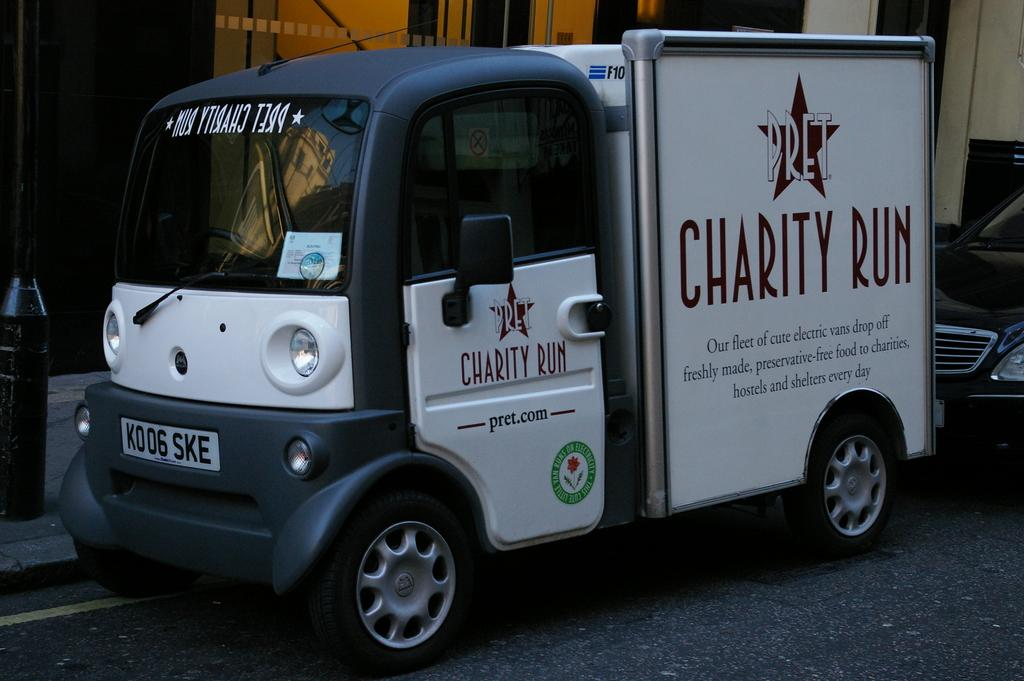What type of objects are present in the image? There are vehicles in the image. What can be found on the vehicles? There is text and logos on the vehicles. What is visible in the background of the image? There is a building in the background of the image. Can you describe another object in the image? There is a pole in the image. What type of honey is being produced by the vehicles in the image? There is no honey production in the image; it features vehicles with text and logos. In which direction are the vehicles attacking in the image? There is no attack or directional movement in the image; the vehicles are stationary. 